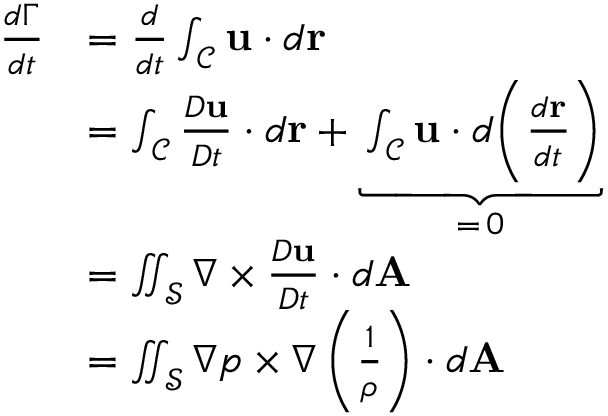<formula> <loc_0><loc_0><loc_500><loc_500>\begin{array} { r l } { \frac { d \Gamma } { d t } } & { = \frac { d } { d t } \int _ { \mathcal { C } } u \cdot d r } \\ & { = \int _ { \mathcal { C } } \frac { D u } { D t } \cdot d r + \underbrace { \int _ { \mathcal { C } } u \cdot d \left ( \frac { d r } { d t } \right ) } _ { = \, 0 } } \\ & { = \iint _ { \mathcal { S } } \nabla \times \frac { D u } { D t } \cdot d A } \\ & { = \iint _ { \mathcal { S } } \nabla p \times \nabla \left ( \frac { 1 } { \rho } \right ) \cdot d A } \end{array}</formula> 